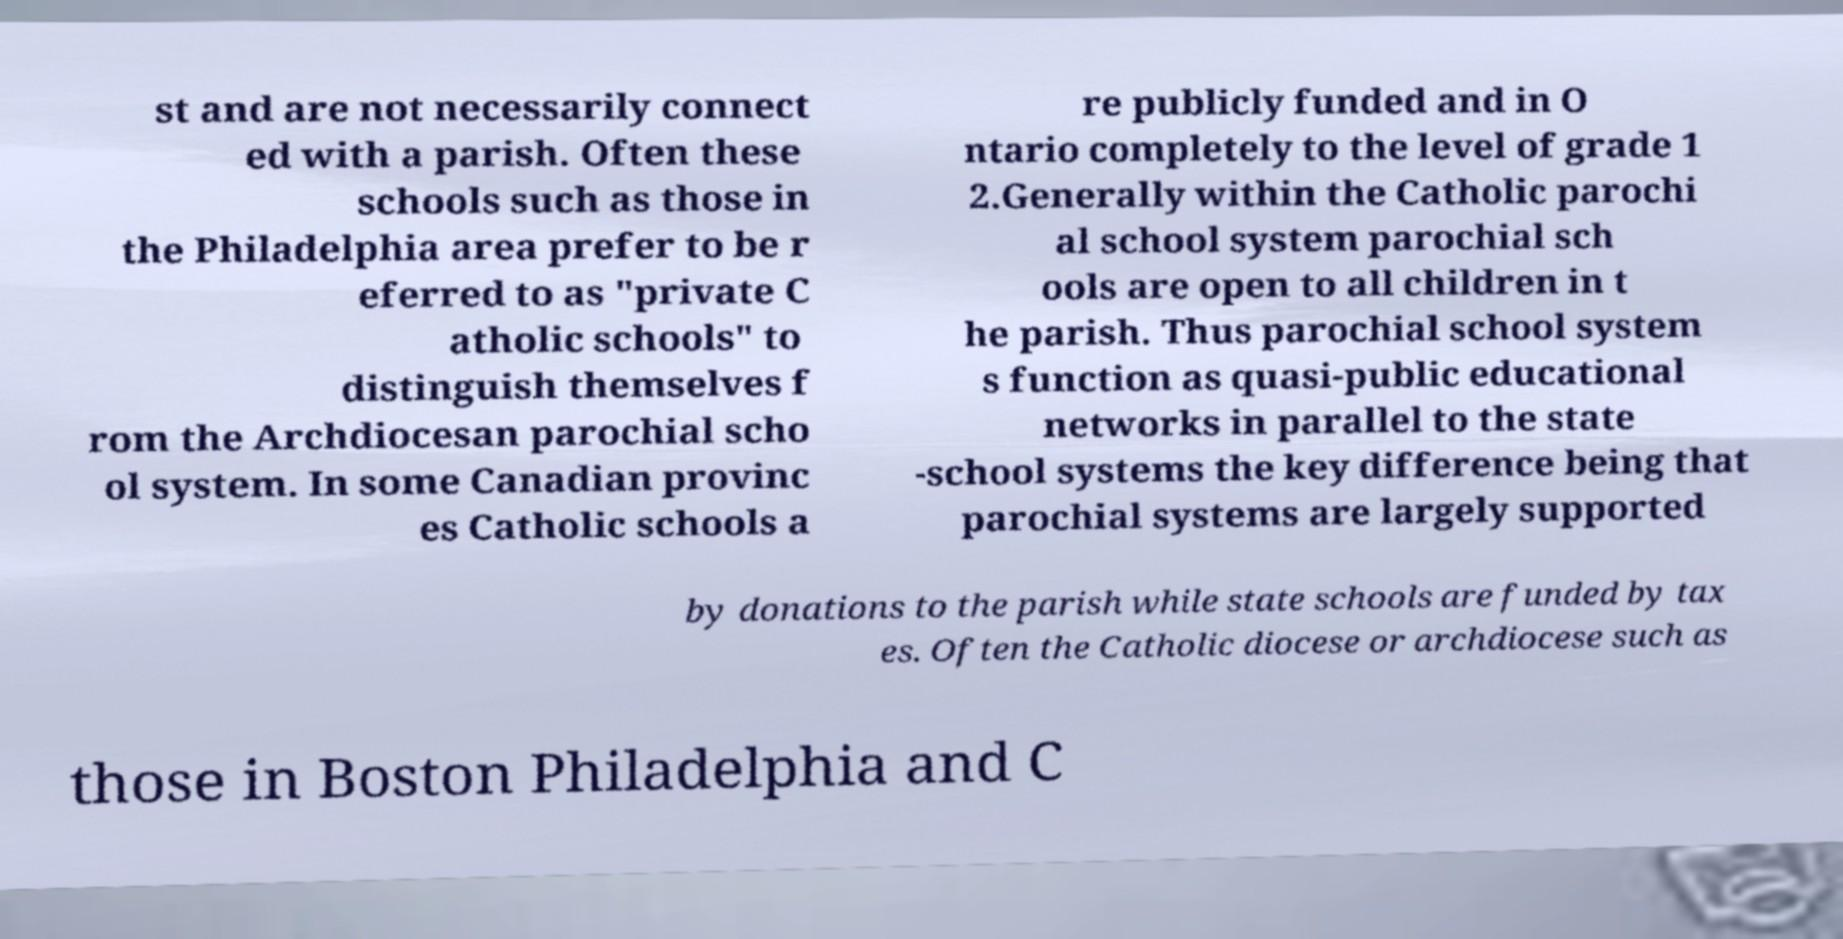What messages or text are displayed in this image? I need them in a readable, typed format. st and are not necessarily connect ed with a parish. Often these schools such as those in the Philadelphia area prefer to be r eferred to as "private C atholic schools" to distinguish themselves f rom the Archdiocesan parochial scho ol system. In some Canadian provinc es Catholic schools a re publicly funded and in O ntario completely to the level of grade 1 2.Generally within the Catholic parochi al school system parochial sch ools are open to all children in t he parish. Thus parochial school system s function as quasi-public educational networks in parallel to the state -school systems the key difference being that parochial systems are largely supported by donations to the parish while state schools are funded by tax es. Often the Catholic diocese or archdiocese such as those in Boston Philadelphia and C 